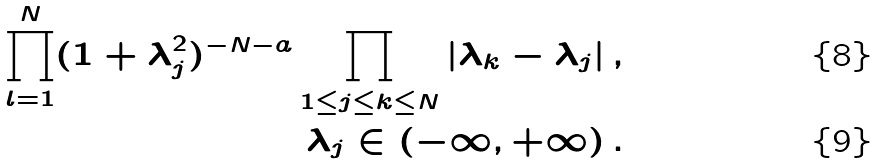<formula> <loc_0><loc_0><loc_500><loc_500>\prod _ { l = 1 } ^ { N } ( 1 + \lambda _ { j } ^ { 2 } ) ^ { - N - a } \prod _ { 1 \leq j \leq k \leq N } | \lambda _ { k } - \lambda _ { j } | \, , & \\ \lambda _ { j } \in ( - \infty , + \infty ) \, . &</formula> 